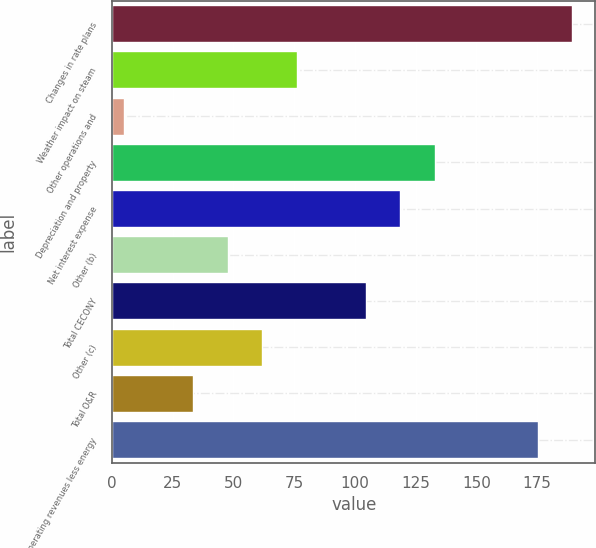Convert chart. <chart><loc_0><loc_0><loc_500><loc_500><bar_chart><fcel>Changes in rate plans<fcel>Weather impact on steam<fcel>Other operations and<fcel>Depreciation and property<fcel>Net interest expense<fcel>Other (b)<fcel>Total CECONY<fcel>Other (c)<fcel>Total O&R<fcel>Operating revenues less energy<nl><fcel>189.6<fcel>76<fcel>5<fcel>132.8<fcel>118.6<fcel>47.6<fcel>104.4<fcel>61.8<fcel>33.4<fcel>175.4<nl></chart> 